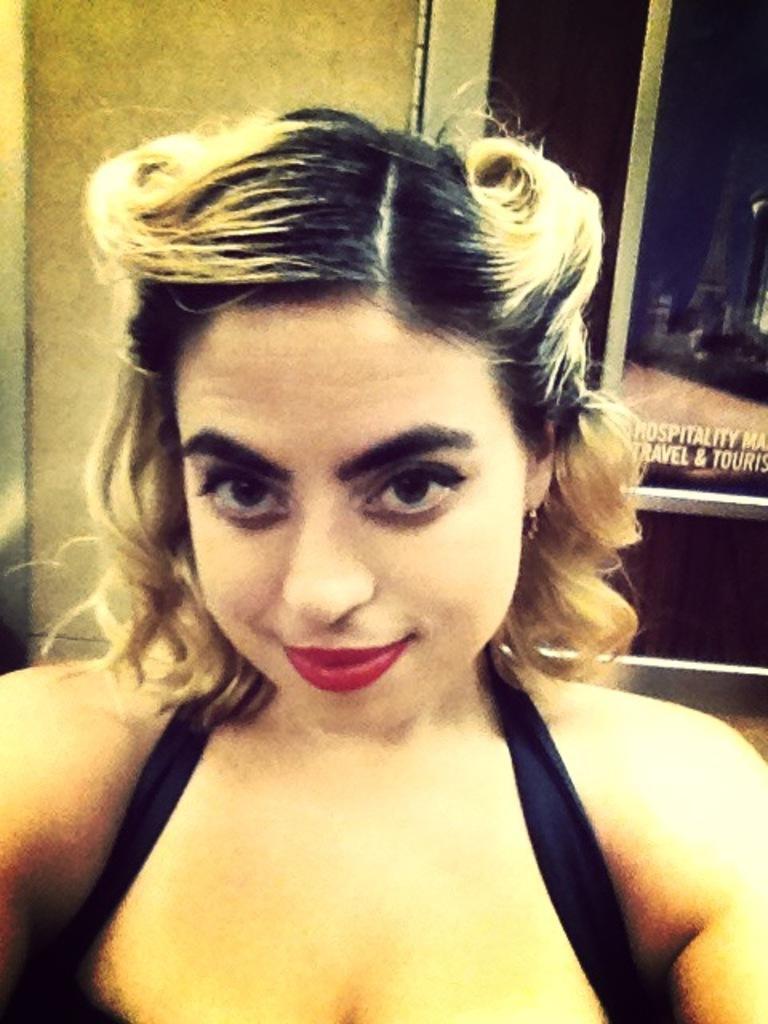Describe this image in one or two sentences. In this image we can see a woman and in the background it looks like a glass door, on the glass door, we can see some text and the wall. 